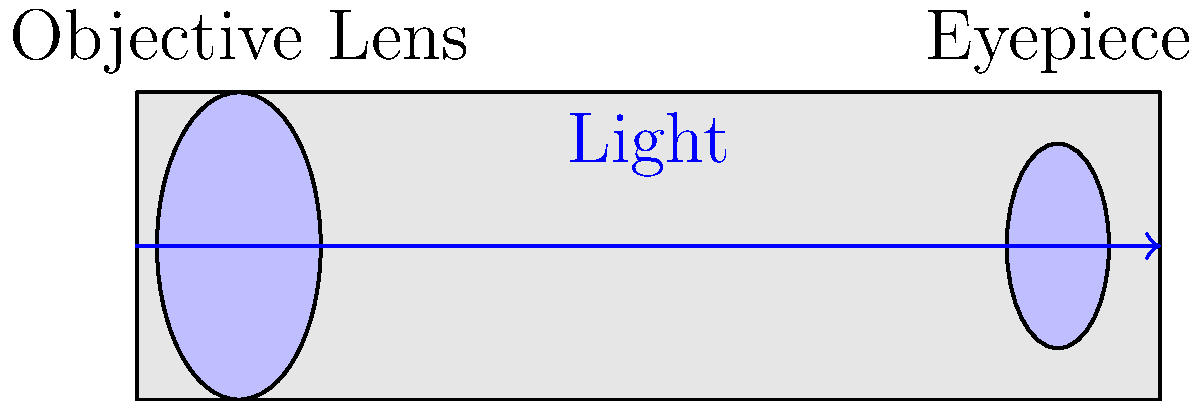In a refracting telescope, how does the objective lens work in conjunction with the eyepiece to produce a magnified image of distant objects? Explain the process in terms of light path and focal points. 1. Light enters the telescope through the objective lens:
   - The objective lens is the larger lens at the front of the telescope.
   - It collects and focuses incoming light from distant objects.

2. The objective lens bends (refracts) the light:
   - Light rays are bent inward as they pass through the lens.
   - This causes the rays to converge at the focal point of the objective lens.

3. Formation of the primary image:
   - The converged light forms an inverted, real image at the focal point of the objective lens.
   - This image is smaller than the object but brighter and more detailed than what the naked eye can see.

4. The eyepiece acts as a magnifying glass:
   - The eyepiece is positioned so that the primary image falls just inside its focal point.
   - It further magnifies the primary image formed by the objective lens.

5. Final image formation:
   - The eyepiece creates a virtual, enlarged, and inverted image of the primary image.
   - This final image appears to be coming from a point beyond the eyepiece, making distant objects appear larger and clearer.

6. Magnification:
   - The overall magnification of the telescope is calculated by dividing the focal length of the objective lens by the focal length of the eyepiece.
   - Mathematically, this can be expressed as: $M = \frac{f_o}{f_e}$, where $M$ is magnification, $f_o$ is the focal length of the objective lens, and $f_e$ is the focal length of the eyepiece.

The combination of the objective lens and eyepiece allows for the collection of more light than the human eye alone and provides significant magnification, enabling the observation of distant celestial objects.
Answer: Objective lens collects and focuses light, forming a primary image; eyepiece magnifies this image, creating an enlarged virtual image for the observer. 